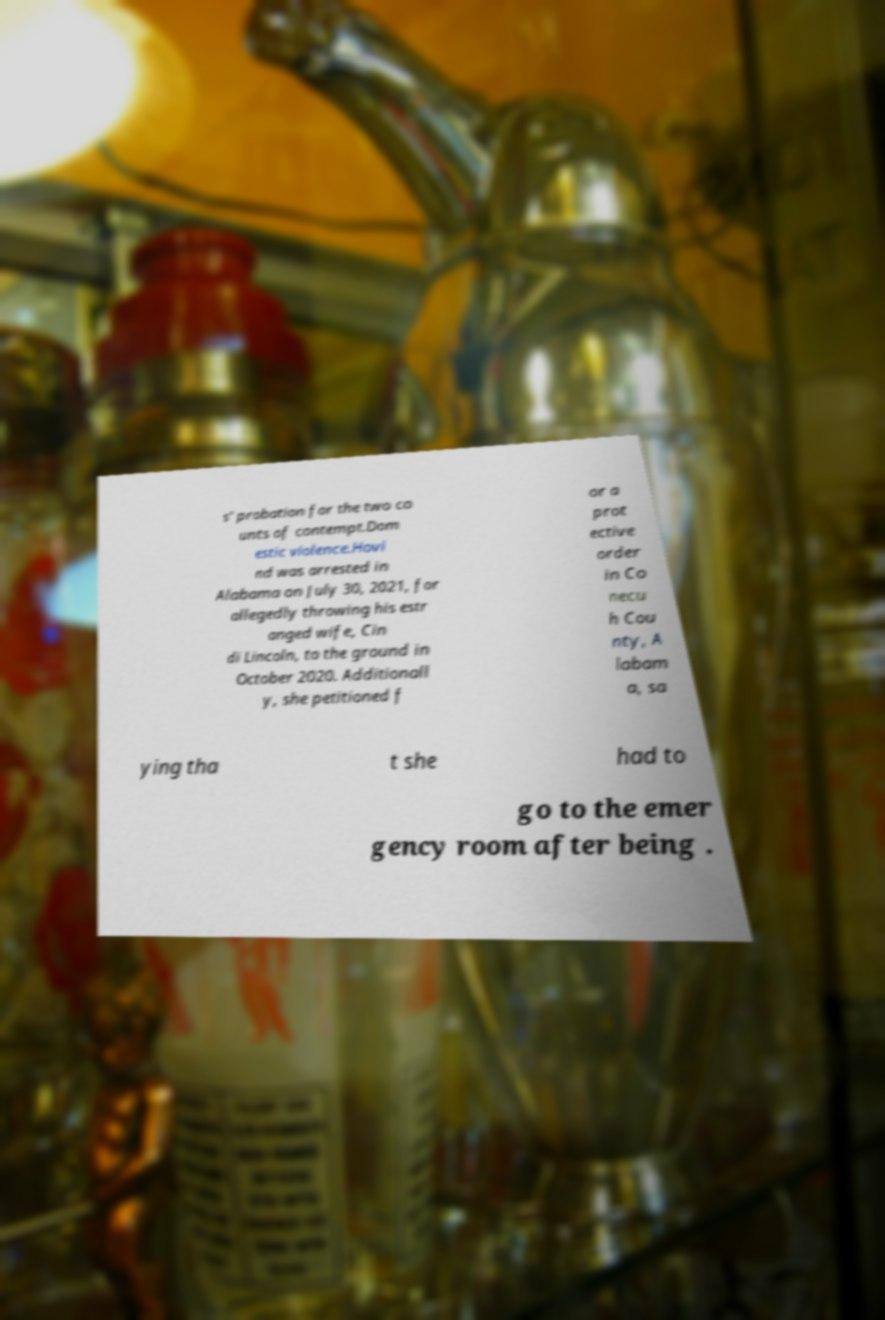Please read and relay the text visible in this image. What does it say? s' probation for the two co unts of contempt.Dom estic violence.Hovi nd was arrested in Alabama on July 30, 2021, for allegedly throwing his estr anged wife, Cin di Lincoln, to the ground in October 2020. Additionall y, she petitioned f or a prot ective order in Co necu h Cou nty, A labam a, sa ying tha t she had to go to the emer gency room after being . 